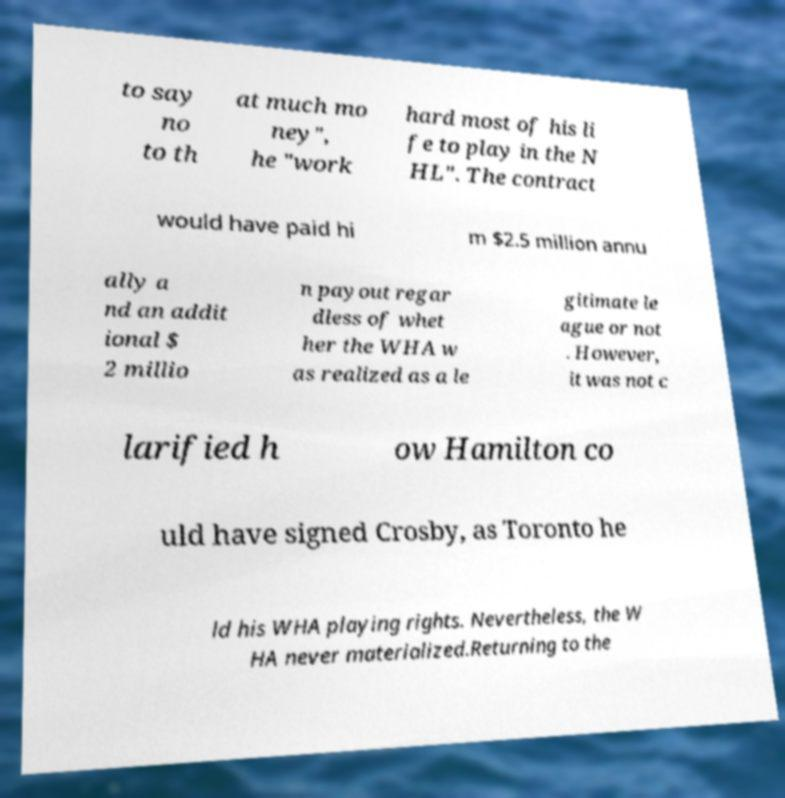Could you extract and type out the text from this image? to say no to th at much mo ney", he "work hard most of his li fe to play in the N HL". The contract would have paid hi m $2.5 million annu ally a nd an addit ional $ 2 millio n payout regar dless of whet her the WHA w as realized as a le gitimate le ague or not . However, it was not c larified h ow Hamilton co uld have signed Crosby, as Toronto he ld his WHA playing rights. Nevertheless, the W HA never materialized.Returning to the 